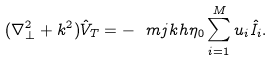Convert formula to latex. <formula><loc_0><loc_0><loc_500><loc_500>( \nabla _ { \perp } ^ { 2 } + k ^ { 2 } ) \hat { V } _ { T } = - \ m j k h \eta _ { 0 } \sum ^ { M } _ { i = 1 } u _ { i } \hat { I _ { i } } .</formula> 